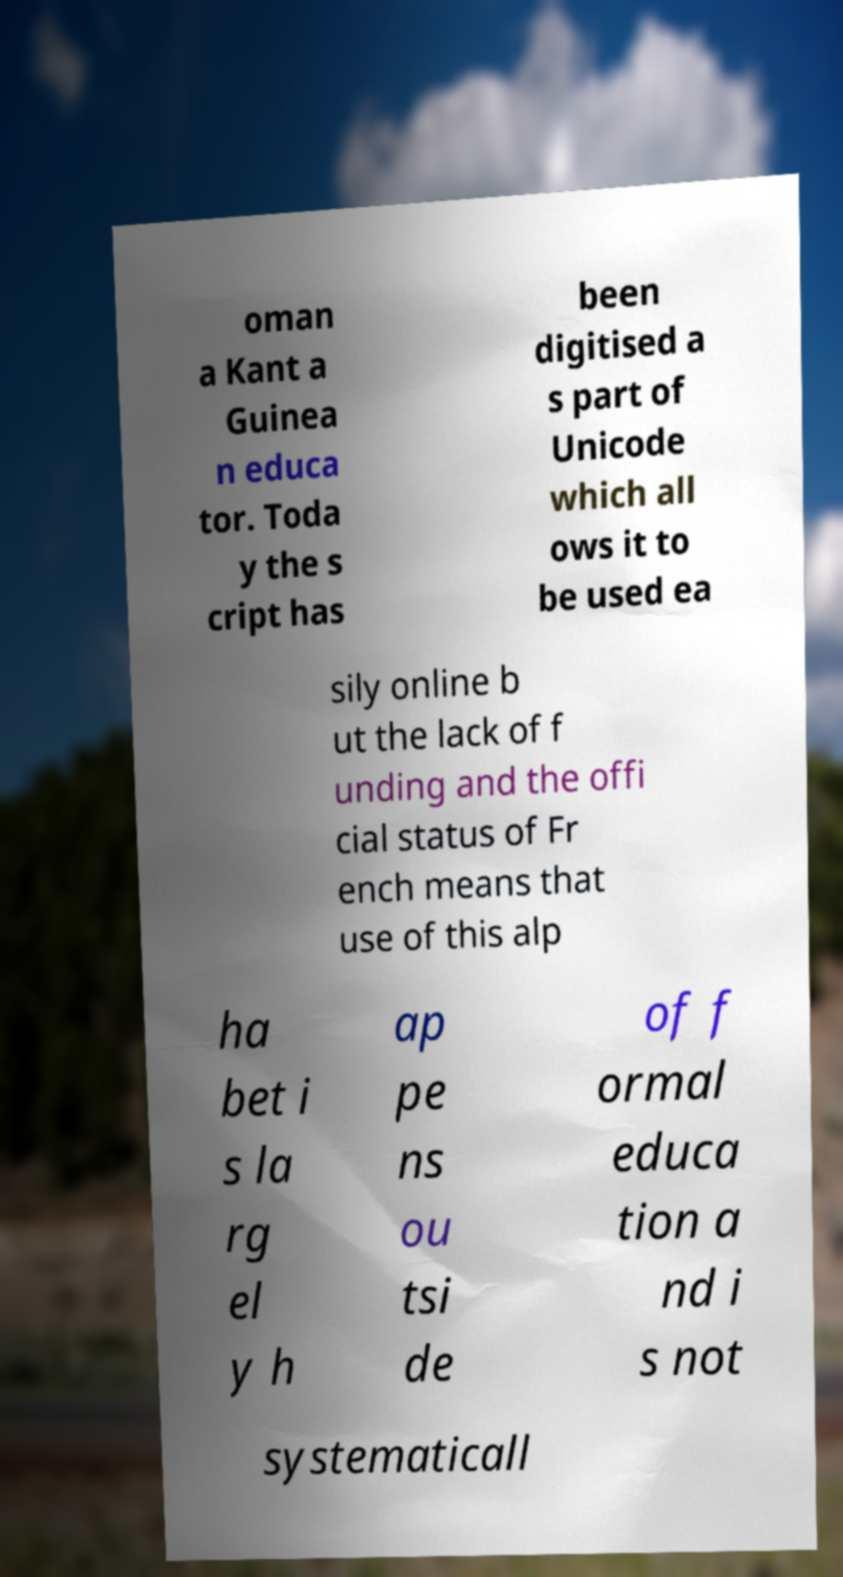There's text embedded in this image that I need extracted. Can you transcribe it verbatim? oman a Kant a Guinea n educa tor. Toda y the s cript has been digitised a s part of Unicode which all ows it to be used ea sily online b ut the lack of f unding and the offi cial status of Fr ench means that use of this alp ha bet i s la rg el y h ap pe ns ou tsi de of f ormal educa tion a nd i s not systematicall 